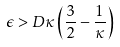<formula> <loc_0><loc_0><loc_500><loc_500>\epsilon > D \kappa \left ( \frac { 3 } { 2 } - \frac { 1 } { \kappa } \right )</formula> 